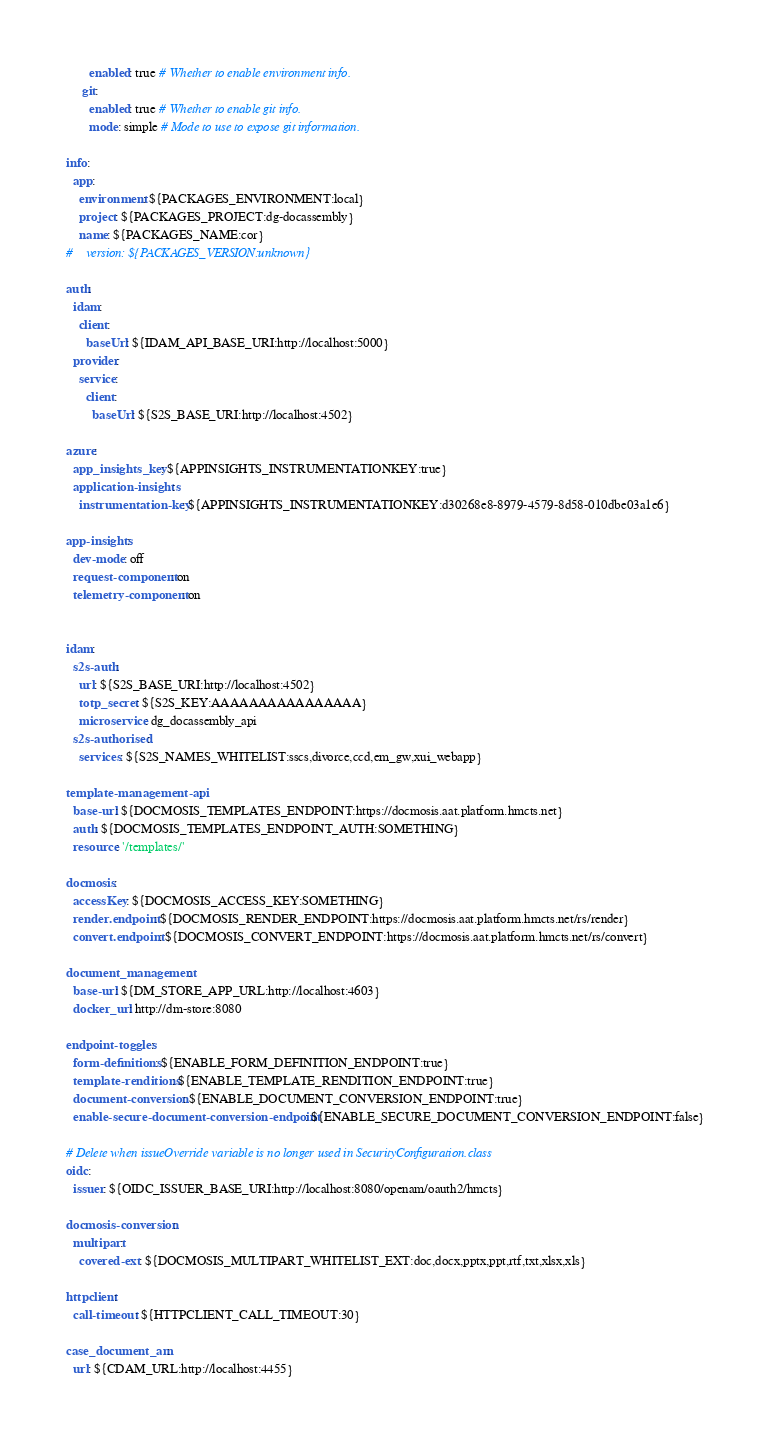<code> <loc_0><loc_0><loc_500><loc_500><_YAML_>       enabled: true # Whether to enable environment info.
     git:
       enabled: true # Whether to enable git info.
       mode: simple # Mode to use to expose git information.

info:
  app:
    environment: ${PACKAGES_ENVIRONMENT:local}
    project: ${PACKAGES_PROJECT:dg-docassembly}
    name: ${PACKAGES_NAME:cor}
#    version: ${PACKAGES_VERSION:unknown}

auth:
  idam:
    client:
      baseUrl: ${IDAM_API_BASE_URI:http://localhost:5000}
  provider:
    service:
      client:
        baseUrl: ${S2S_BASE_URI:http://localhost:4502}

azure:
  app_insights_key: ${APPINSIGHTS_INSTRUMENTATIONKEY:true}
  application-insights:
    instrumentation-key: ${APPINSIGHTS_INSTRUMENTATIONKEY:d30268e8-8979-4579-8d58-010dbe03a1e6}

app-insights:
  dev-mode: off
  request-component: on
  telemetry-component: on


idam:
  s2s-auth:
    url: ${S2S_BASE_URI:http://localhost:4502}
    totp_secret: ${S2S_KEY:AAAAAAAAAAAAAAAA}
    microservice: dg_docassembly_api
  s2s-authorised:
    services: ${S2S_NAMES_WHITELIST:sscs,divorce,ccd,em_gw,xui_webapp}

template-management-api:
  base-url: ${DOCMOSIS_TEMPLATES_ENDPOINT:https://docmosis.aat.platform.hmcts.net}
  auth: ${DOCMOSIS_TEMPLATES_ENDPOINT_AUTH:SOMETHING}
  resource: '/templates/'

docmosis:
  accessKey: ${DOCMOSIS_ACCESS_KEY:SOMETHING}
  render.endpoint: ${DOCMOSIS_RENDER_ENDPOINT:https://docmosis.aat.platform.hmcts.net/rs/render}
  convert.endpoint: ${DOCMOSIS_CONVERT_ENDPOINT:https://docmosis.aat.platform.hmcts.net/rs/convert}

document_management:
  base-url: ${DM_STORE_APP_URL:http://localhost:4603}
  docker_url: http://dm-store:8080

endpoint-toggles:
  form-definitions: ${ENABLE_FORM_DEFINITION_ENDPOINT:true}
  template-renditions: ${ENABLE_TEMPLATE_RENDITION_ENDPOINT:true}
  document-conversion: ${ENABLE_DOCUMENT_CONVERSION_ENDPOINT:true}
  enable-secure-document-conversion-endpoint: ${ENABLE_SECURE_DOCUMENT_CONVERSION_ENDPOINT:false}

# Delete when issueOverride variable is no longer used in SecurityConfiguration.class
oidc:
  issuer: ${OIDC_ISSUER_BASE_URI:http://localhost:8080/openam/oauth2/hmcts}

docmosis-conversion:
  multipart:
    covered-ext: ${DOCMOSIS_MULTIPART_WHITELIST_EXT:doc,docx,pptx,ppt,rtf,txt,xlsx,xls}

httpclient:
  call-timeout: ${HTTPCLIENT_CALL_TIMEOUT:30}

case_document_am:
  url: ${CDAM_URL:http://localhost:4455}</code> 